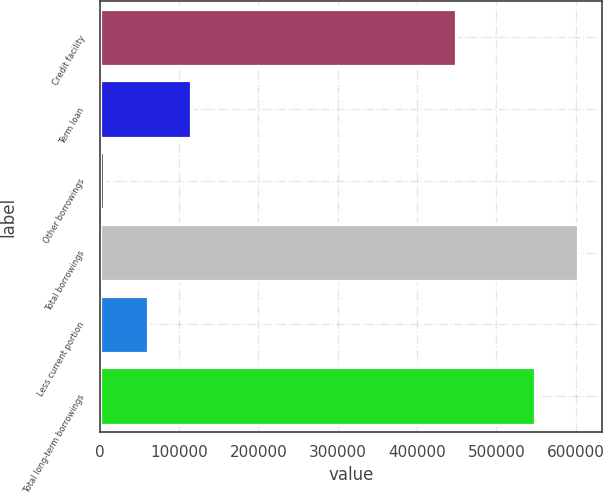Convert chart. <chart><loc_0><loc_0><loc_500><loc_500><bar_chart><fcel>Credit facility<fcel>Term loan<fcel>Other borrowings<fcel>Total borrowings<fcel>Less current portion<fcel>Total long-term borrowings<nl><fcel>448763<fcel>114990<fcel>5237<fcel>603020<fcel>60113.3<fcel>548144<nl></chart> 